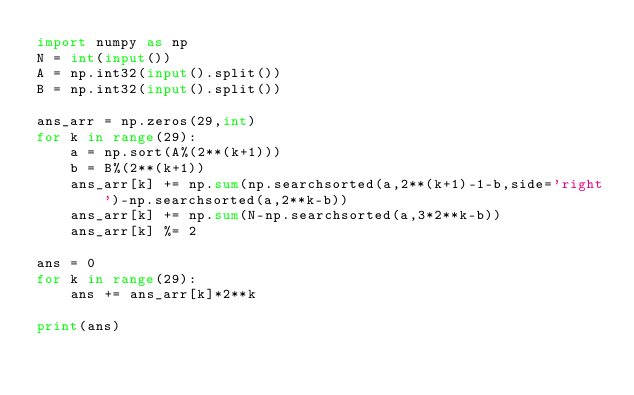<code> <loc_0><loc_0><loc_500><loc_500><_Python_>import numpy as np
N = int(input())
A = np.int32(input().split())
B = np.int32(input().split())

ans_arr = np.zeros(29,int)
for k in range(29):
    a = np.sort(A%(2**(k+1)))
    b = B%(2**(k+1))
    ans_arr[k] += np.sum(np.searchsorted(a,2**(k+1)-1-b,side='right')-np.searchsorted(a,2**k-b))
    ans_arr[k] += np.sum(N-np.searchsorted(a,3*2**k-b))
    ans_arr[k] %= 2

ans = 0
for k in range(29):
    ans += ans_arr[k]*2**k

print(ans)</code> 